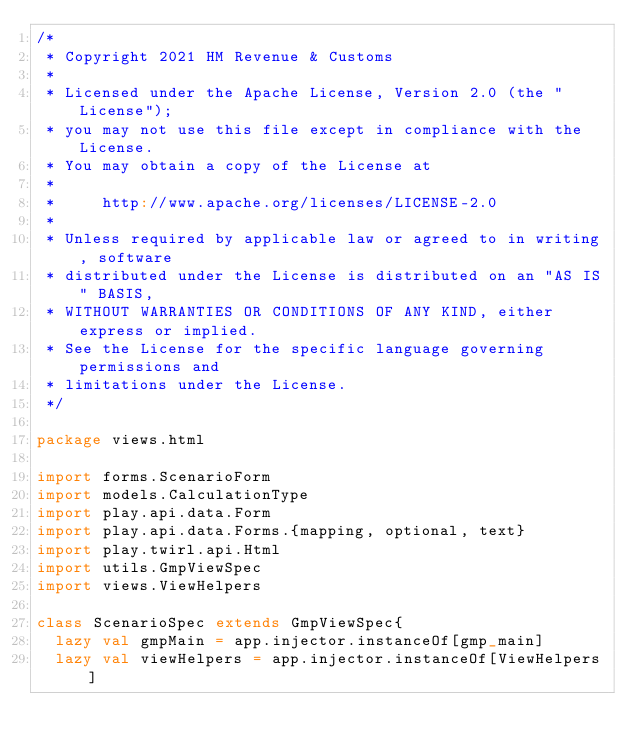Convert code to text. <code><loc_0><loc_0><loc_500><loc_500><_Scala_>/*
 * Copyright 2021 HM Revenue & Customs
 *
 * Licensed under the Apache License, Version 2.0 (the "License");
 * you may not use this file except in compliance with the License.
 * You may obtain a copy of the License at
 *
 *     http://www.apache.org/licenses/LICENSE-2.0
 *
 * Unless required by applicable law or agreed to in writing, software
 * distributed under the License is distributed on an "AS IS" BASIS,
 * WITHOUT WARRANTIES OR CONDITIONS OF ANY KIND, either express or implied.
 * See the License for the specific language governing permissions and
 * limitations under the License.
 */

package views.html

import forms.ScenarioForm
import models.CalculationType
import play.api.data.Form
import play.api.data.Forms.{mapping, optional, text}
import play.twirl.api.Html
import utils.GmpViewSpec
import views.ViewHelpers

class ScenarioSpec extends GmpViewSpec{
  lazy val gmpMain = app.injector.instanceOf[gmp_main]
  lazy val viewHelpers = app.injector.instanceOf[ViewHelpers]
</code> 